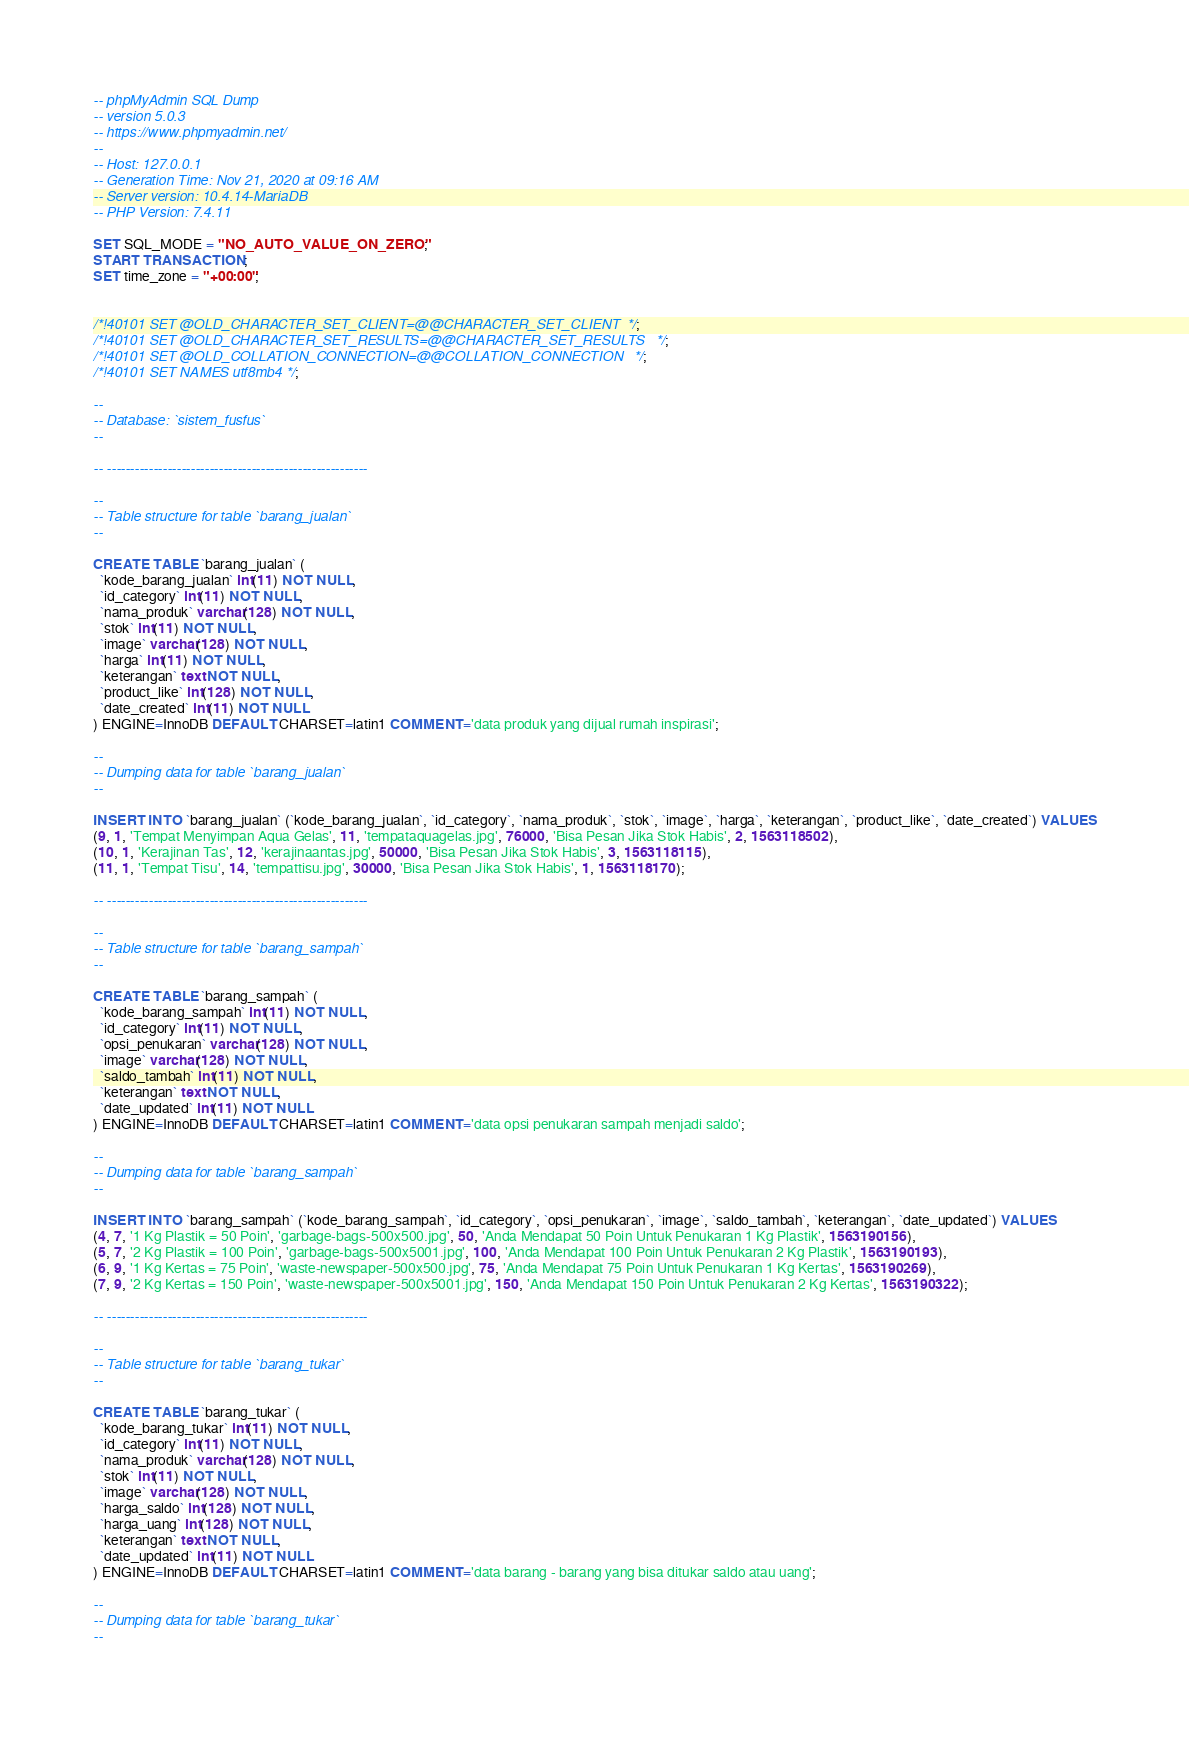Convert code to text. <code><loc_0><loc_0><loc_500><loc_500><_SQL_>-- phpMyAdmin SQL Dump
-- version 5.0.3
-- https://www.phpmyadmin.net/
--
-- Host: 127.0.0.1
-- Generation Time: Nov 21, 2020 at 09:16 AM
-- Server version: 10.4.14-MariaDB
-- PHP Version: 7.4.11

SET SQL_MODE = "NO_AUTO_VALUE_ON_ZERO";
START TRANSACTION;
SET time_zone = "+00:00";


/*!40101 SET @OLD_CHARACTER_SET_CLIENT=@@CHARACTER_SET_CLIENT */;
/*!40101 SET @OLD_CHARACTER_SET_RESULTS=@@CHARACTER_SET_RESULTS */;
/*!40101 SET @OLD_COLLATION_CONNECTION=@@COLLATION_CONNECTION */;
/*!40101 SET NAMES utf8mb4 */;

--
-- Database: `sistem_fusfus`
--

-- --------------------------------------------------------

--
-- Table structure for table `barang_jualan`
--

CREATE TABLE `barang_jualan` (
  `kode_barang_jualan` int(11) NOT NULL,
  `id_category` int(11) NOT NULL,
  `nama_produk` varchar(128) NOT NULL,
  `stok` int(11) NOT NULL,
  `image` varchar(128) NOT NULL,
  `harga` int(11) NOT NULL,
  `keterangan` text NOT NULL,
  `product_like` int(128) NOT NULL,
  `date_created` int(11) NOT NULL
) ENGINE=InnoDB DEFAULT CHARSET=latin1 COMMENT='data produk yang dijual rumah inspirasi';

--
-- Dumping data for table `barang_jualan`
--

INSERT INTO `barang_jualan` (`kode_barang_jualan`, `id_category`, `nama_produk`, `stok`, `image`, `harga`, `keterangan`, `product_like`, `date_created`) VALUES
(9, 1, 'Tempat Menyimpan Aqua Gelas', 11, 'tempataquagelas.jpg', 76000, 'Bisa Pesan Jika Stok Habis', 2, 1563118502),
(10, 1, 'Kerajinan Tas', 12, 'kerajinaantas.jpg', 50000, 'Bisa Pesan Jika Stok Habis', 3, 1563118115),
(11, 1, 'Tempat Tisu', 14, 'tempattisu.jpg', 30000, 'Bisa Pesan Jika Stok Habis', 1, 1563118170);

-- --------------------------------------------------------

--
-- Table structure for table `barang_sampah`
--

CREATE TABLE `barang_sampah` (
  `kode_barang_sampah` int(11) NOT NULL,
  `id_category` int(11) NOT NULL,
  `opsi_penukaran` varchar(128) NOT NULL,
  `image` varchar(128) NOT NULL,
  `saldo_tambah` int(11) NOT NULL,
  `keterangan` text NOT NULL,
  `date_updated` int(11) NOT NULL
) ENGINE=InnoDB DEFAULT CHARSET=latin1 COMMENT='data opsi penukaran sampah menjadi saldo';

--
-- Dumping data for table `barang_sampah`
--

INSERT INTO `barang_sampah` (`kode_barang_sampah`, `id_category`, `opsi_penukaran`, `image`, `saldo_tambah`, `keterangan`, `date_updated`) VALUES
(4, 7, '1 Kg Plastik = 50 Poin', 'garbage-bags-500x500.jpg', 50, 'Anda Mendapat 50 Poin Untuk Penukaran 1 Kg Plastik', 1563190156),
(5, 7, '2 Kg Plastik = 100 Poin', 'garbage-bags-500x5001.jpg', 100, 'Anda Mendapat 100 Poin Untuk Penukaran 2 Kg Plastik', 1563190193),
(6, 9, '1 Kg Kertas = 75 Poin', 'waste-newspaper-500x500.jpg', 75, 'Anda Mendapat 75 Poin Untuk Penukaran 1 Kg Kertas', 1563190269),
(7, 9, '2 Kg Kertas = 150 Poin', 'waste-newspaper-500x5001.jpg', 150, 'Anda Mendapat 150 Poin Untuk Penukaran 2 Kg Kertas', 1563190322);

-- --------------------------------------------------------

--
-- Table structure for table `barang_tukar`
--

CREATE TABLE `barang_tukar` (
  `kode_barang_tukar` int(11) NOT NULL,
  `id_category` int(11) NOT NULL,
  `nama_produk` varchar(128) NOT NULL,
  `stok` int(11) NOT NULL,
  `image` varchar(128) NOT NULL,
  `harga_saldo` int(128) NOT NULL,
  `harga_uang` int(128) NOT NULL,
  `keterangan` text NOT NULL,
  `date_updated` int(11) NOT NULL
) ENGINE=InnoDB DEFAULT CHARSET=latin1 COMMENT='data barang - barang yang bisa ditukar saldo atau uang';

--
-- Dumping data for table `barang_tukar`
--
</code> 